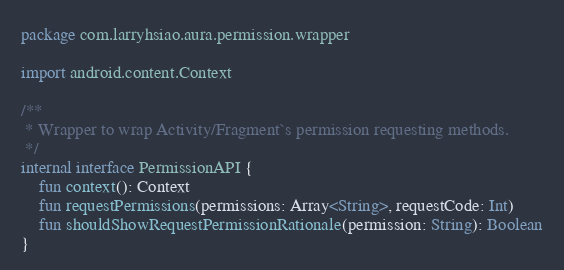<code> <loc_0><loc_0><loc_500><loc_500><_Kotlin_>package com.larryhsiao.aura.permission.wrapper

import android.content.Context

/**
 * Wrapper to wrap Activity/Fragment`s permission requesting methods.
 */
internal interface PermissionAPI {
    fun context(): Context
    fun requestPermissions(permissions: Array<String>, requestCode: Int)
    fun shouldShowRequestPermissionRationale(permission: String): Boolean
}</code> 